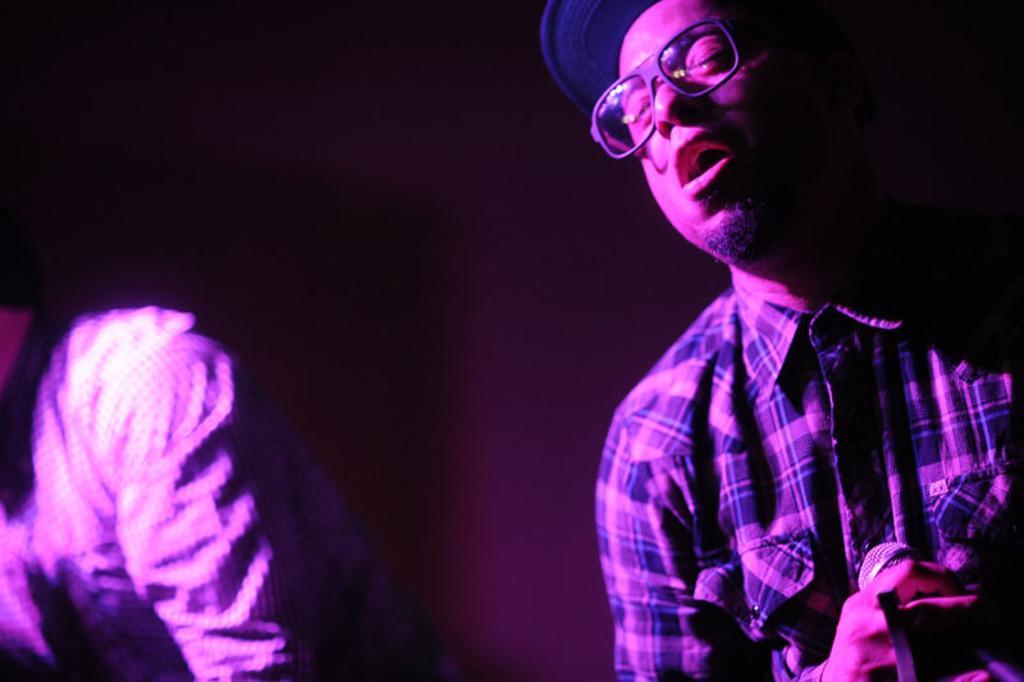In one or two sentences, can you explain what this image depicts? In this image i can see two men. The left side of the man is holding a microphone and wearing a glasses. 